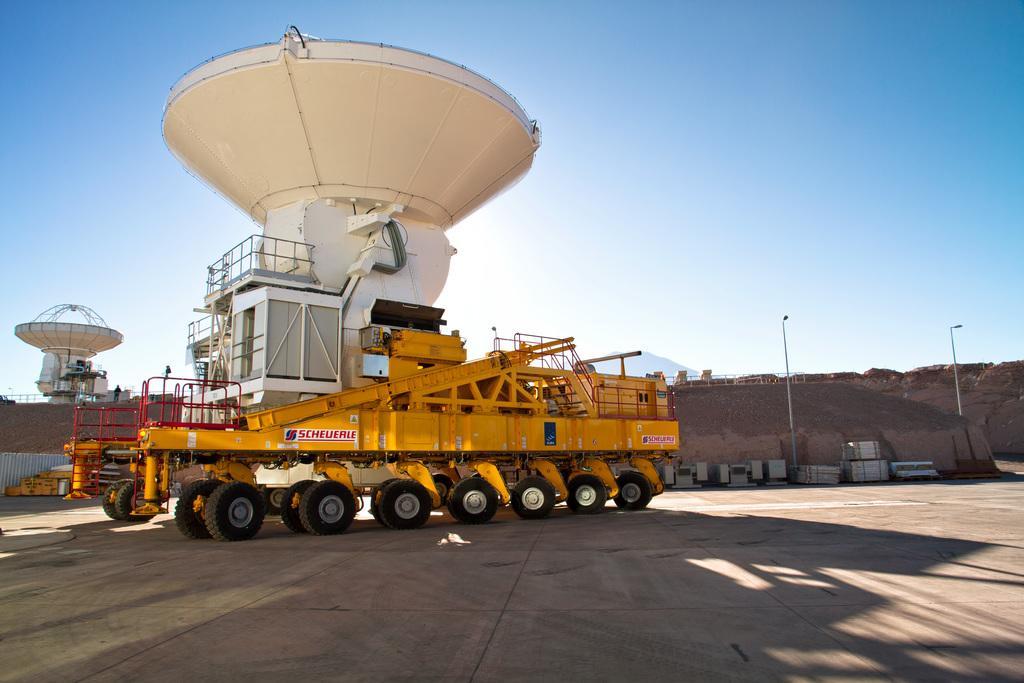Describe this image in one or two sentences. In this image there is a machine on a vehicle, in the background there is equipment and soil and the sky. 